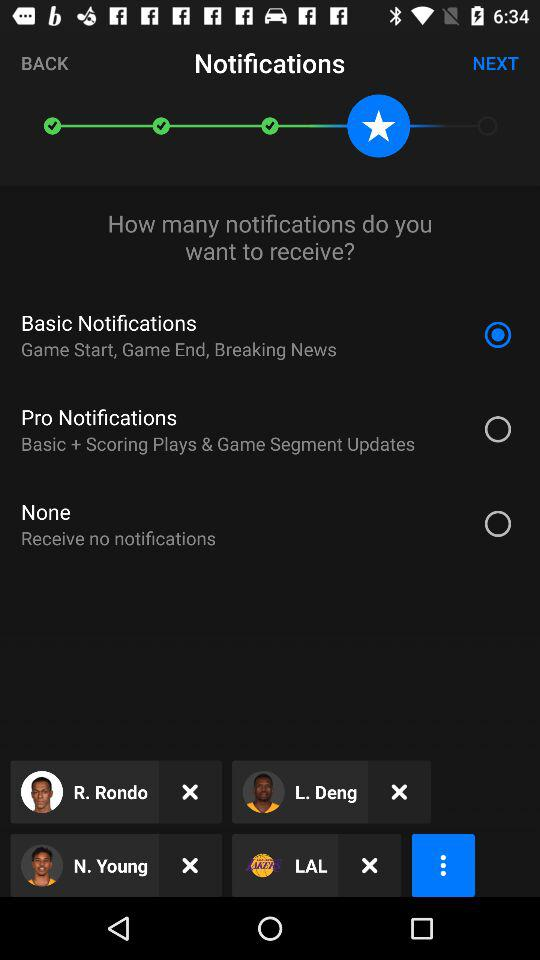Is "Basic Notifications" selected or not?
Answer the question using a single word or phrase. It is selected. 